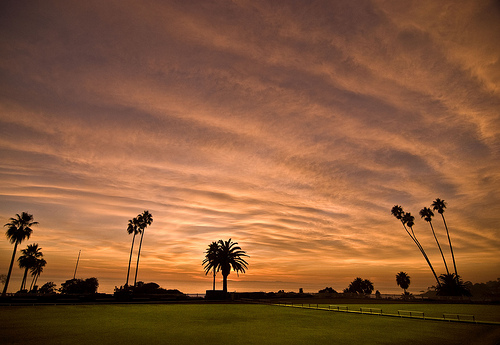<image>
Is there a clouds on the palm tree? No. The clouds is not positioned on the palm tree. They may be near each other, but the clouds is not supported by or resting on top of the palm tree. 